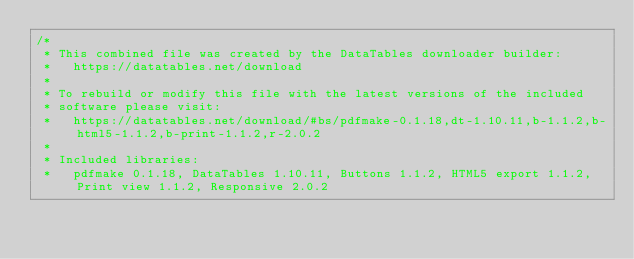<code> <loc_0><loc_0><loc_500><loc_500><_CSS_>/*
 * This combined file was created by the DataTables downloader builder:
 *   https://datatables.net/download
 *
 * To rebuild or modify this file with the latest versions of the included
 * software please visit:
 *   https://datatables.net/download/#bs/pdfmake-0.1.18,dt-1.10.11,b-1.1.2,b-html5-1.1.2,b-print-1.1.2,r-2.0.2
 *
 * Included libraries:
 *   pdfmake 0.1.18, DataTables 1.10.11, Buttons 1.1.2, HTML5 export 1.1.2, Print view 1.1.2, Responsive 2.0.2</code> 